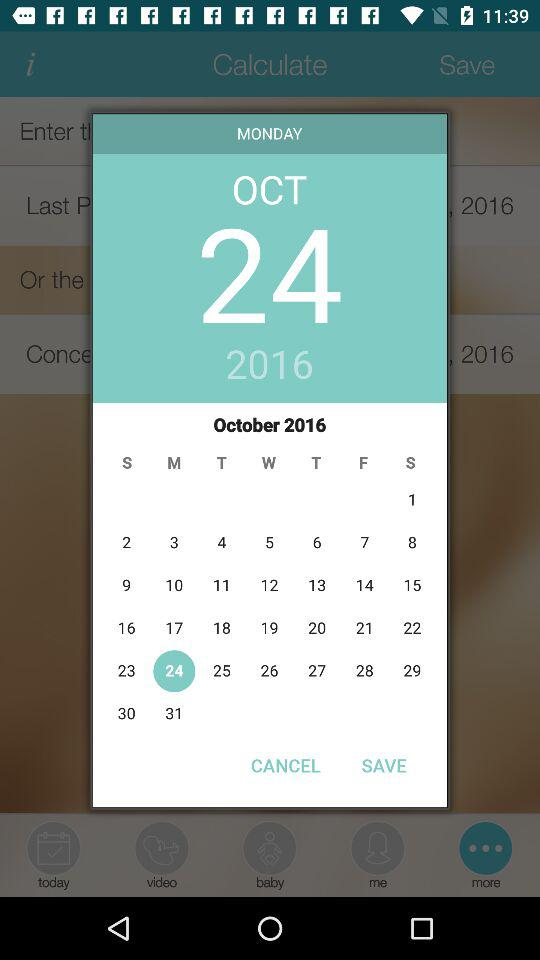What day comes on October 24, 2016? The day is Monday. 